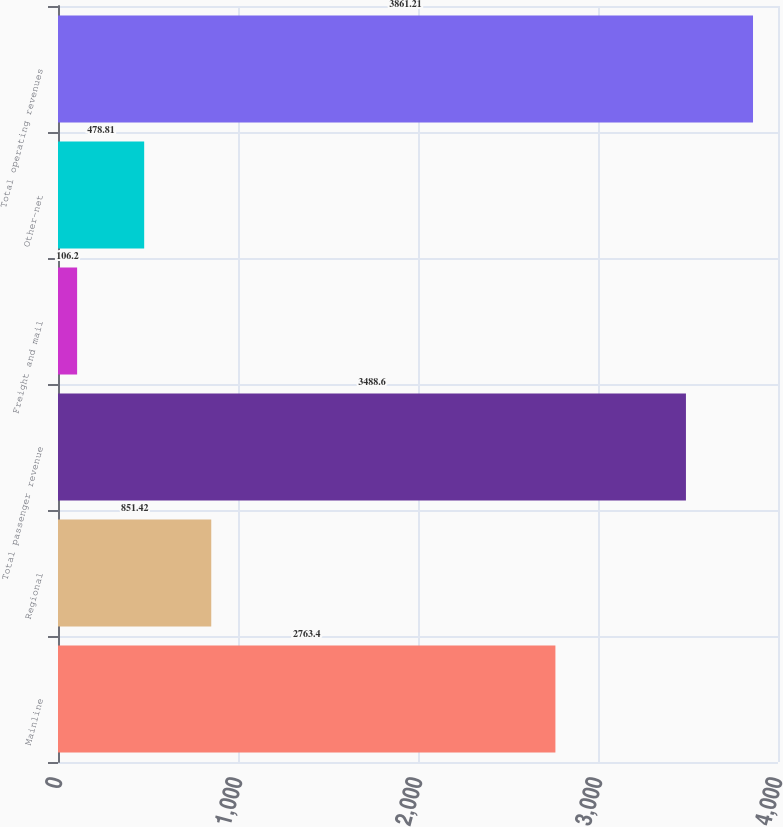Convert chart. <chart><loc_0><loc_0><loc_500><loc_500><bar_chart><fcel>Mainline<fcel>Regional<fcel>Total passenger revenue<fcel>Freight and mail<fcel>Other-net<fcel>Total operating revenues<nl><fcel>2763.4<fcel>851.42<fcel>3488.6<fcel>106.2<fcel>478.81<fcel>3861.21<nl></chart> 